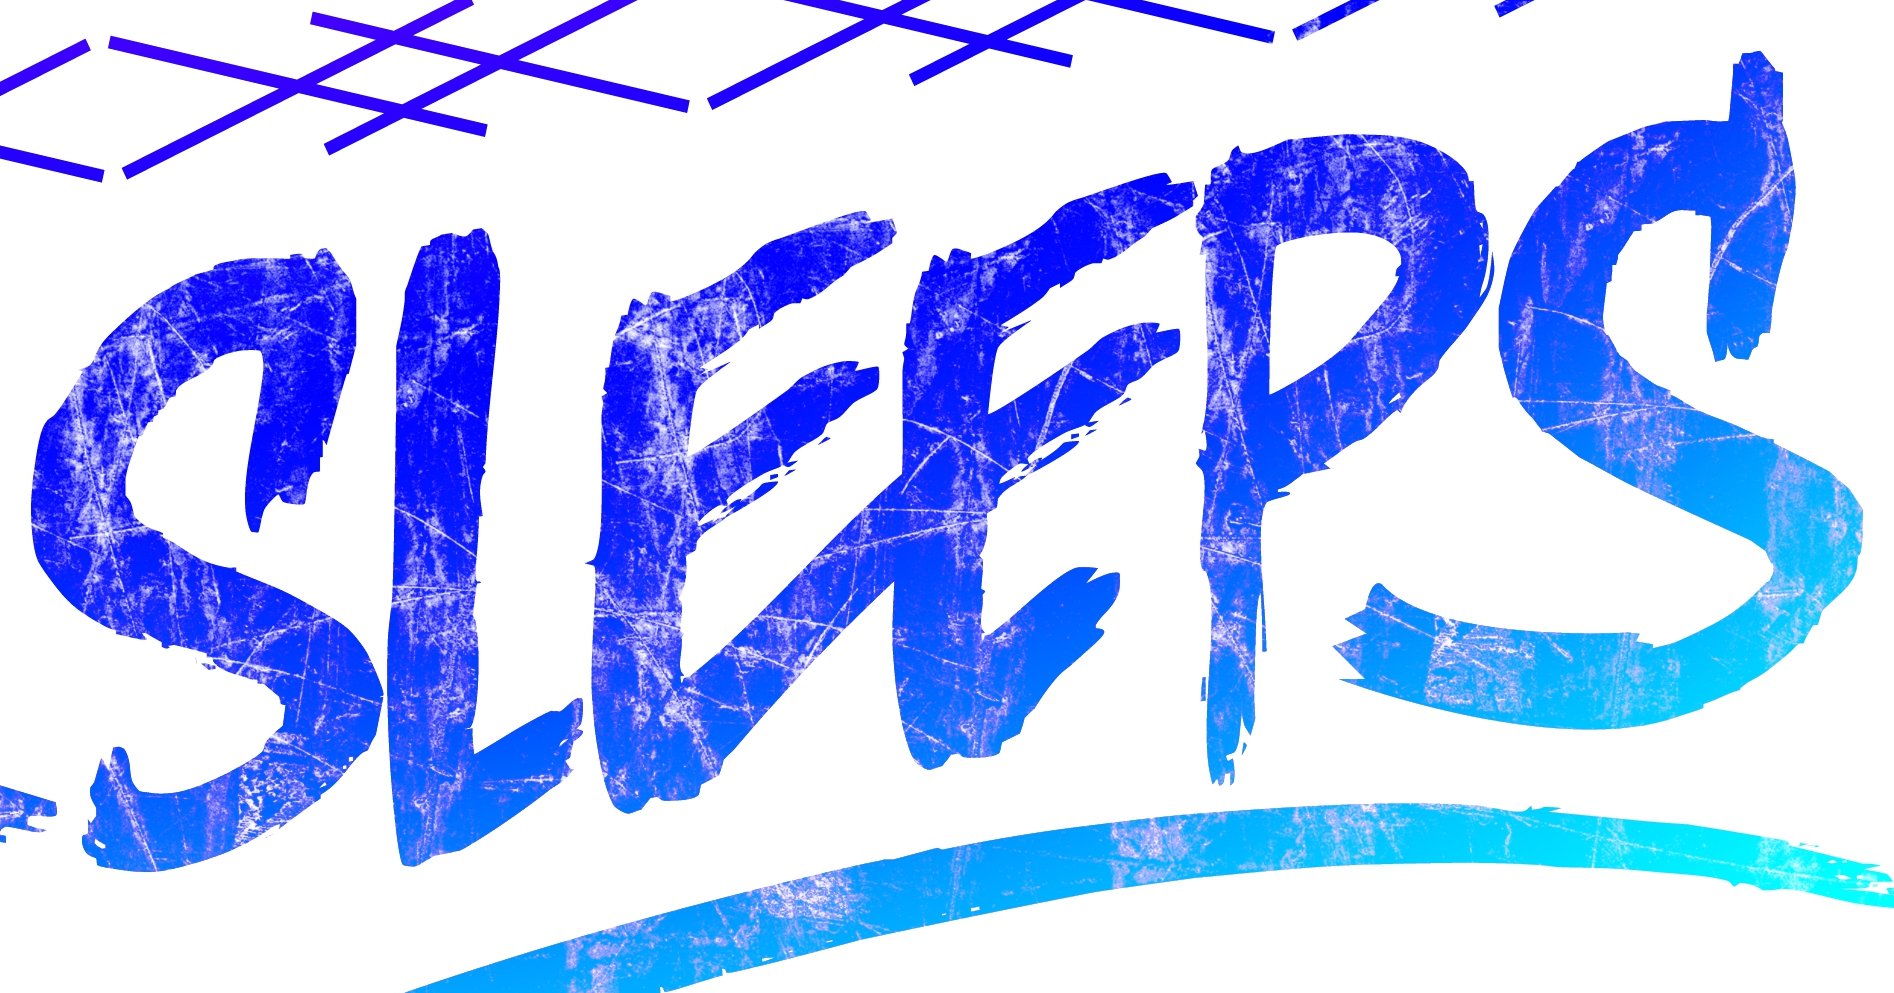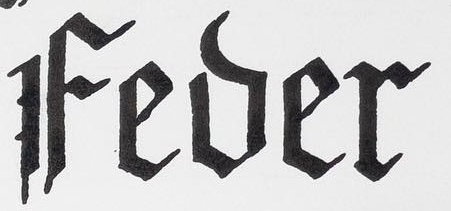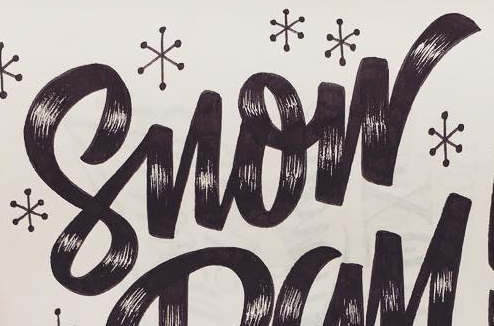Read the text content from these images in order, separated by a semicolon. SLEEPS; Fever; Snow 